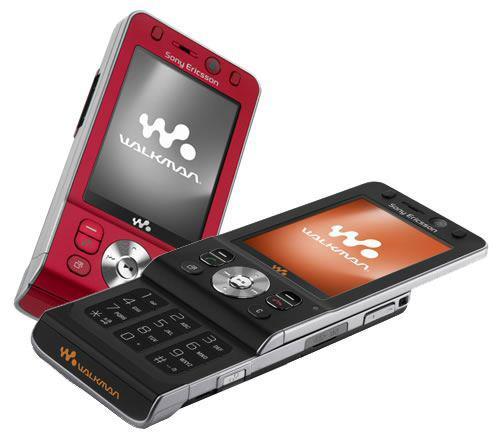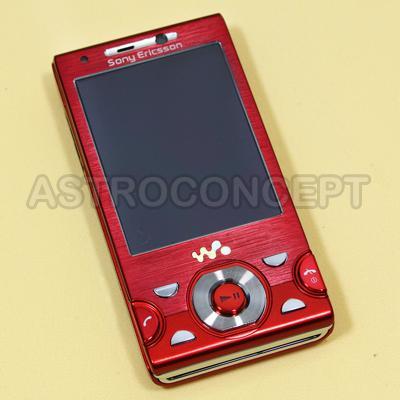The first image is the image on the left, the second image is the image on the right. Examine the images to the left and right. Is the description "There are exactly two phones." accurate? Answer yes or no. No. The first image is the image on the left, the second image is the image on the right. Examine the images to the left and right. Is the description "There are only two phones." accurate? Answer yes or no. No. 